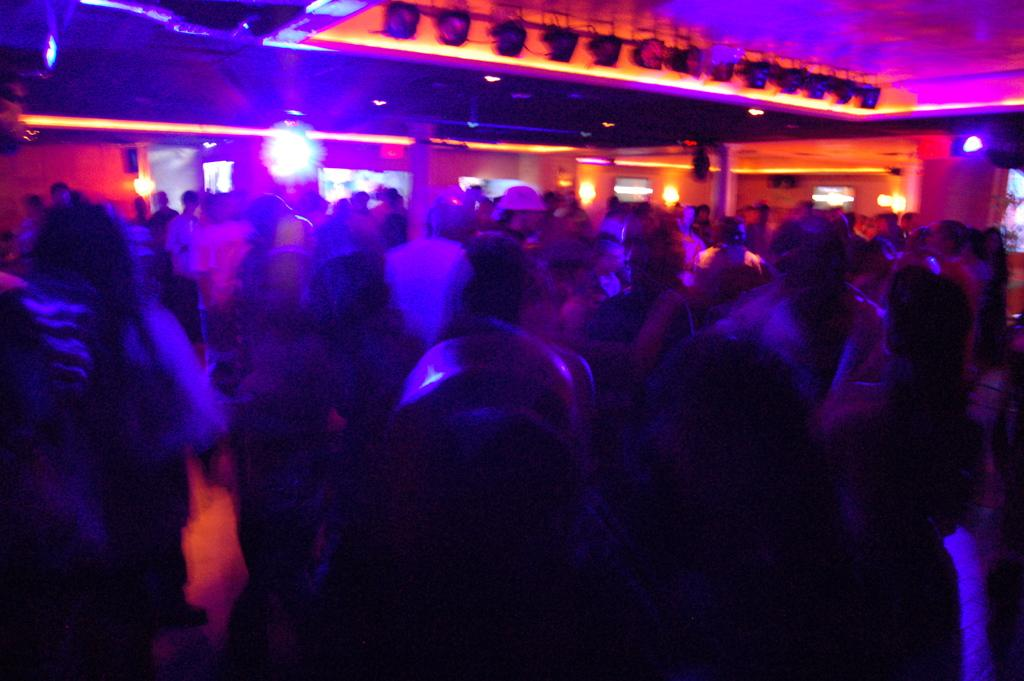Who or what is present in the image? There are people in the image. What can be seen illuminating the scene in the image? There are lights visible in the image. What architectural features can be seen in the background of the image? There are pillars in the background of the image. Can you tell me how many stamps are on the water in the image? There is no water or stamps present in the image. What type of sugar is being used by the people in the image? There is no sugar visible in the image, and the activities of the people are not described. 